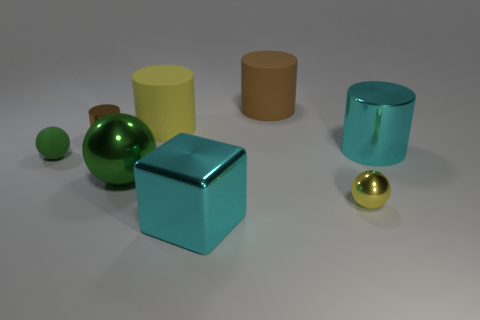Subtract 1 cylinders. How many cylinders are left? 3 Add 1 big cyan shiny spheres. How many objects exist? 9 Subtract all blocks. How many objects are left? 7 Add 1 cyan blocks. How many cyan blocks are left? 2 Add 5 small red matte balls. How many small red matte balls exist? 5 Subtract 0 cyan balls. How many objects are left? 8 Subtract all tiny cyan rubber cylinders. Subtract all green rubber things. How many objects are left? 7 